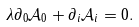<formula> <loc_0><loc_0><loc_500><loc_500>\lambda \partial _ { 0 } { \mathcal { A } } _ { 0 } + \partial _ { i } { \mathcal { A } } _ { i } = 0 .</formula> 